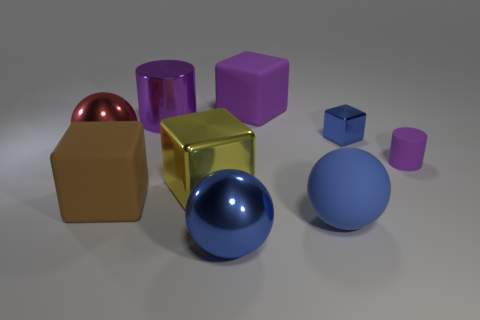What is the size of the block that is the same color as the shiny cylinder?
Your answer should be compact. Large. What number of rubber objects have the same color as the small metal object?
Keep it short and to the point. 1. There is another cube that is the same material as the yellow block; what is its size?
Offer a terse response. Small. Does the matte thing behind the large red shiny thing have the same color as the shiny cylinder?
Provide a succinct answer. Yes. Is the metallic cylinder the same color as the small cylinder?
Offer a terse response. Yes. Is the big cylinder behind the big red metallic thing made of the same material as the cube that is on the right side of the large blue rubber thing?
Make the answer very short. Yes. Is the number of large brown rubber blocks that are behind the large brown cube less than the number of tiny purple cylinders?
Offer a terse response. Yes. There is a blue shiny object that is behind the large red thing; how many tiny purple cylinders are right of it?
Keep it short and to the point. 1. How big is the blue object that is on the left side of the small blue block and on the right side of the large purple block?
Offer a terse response. Large. Are the large yellow thing and the small thing that is behind the large red sphere made of the same material?
Provide a short and direct response. Yes. 